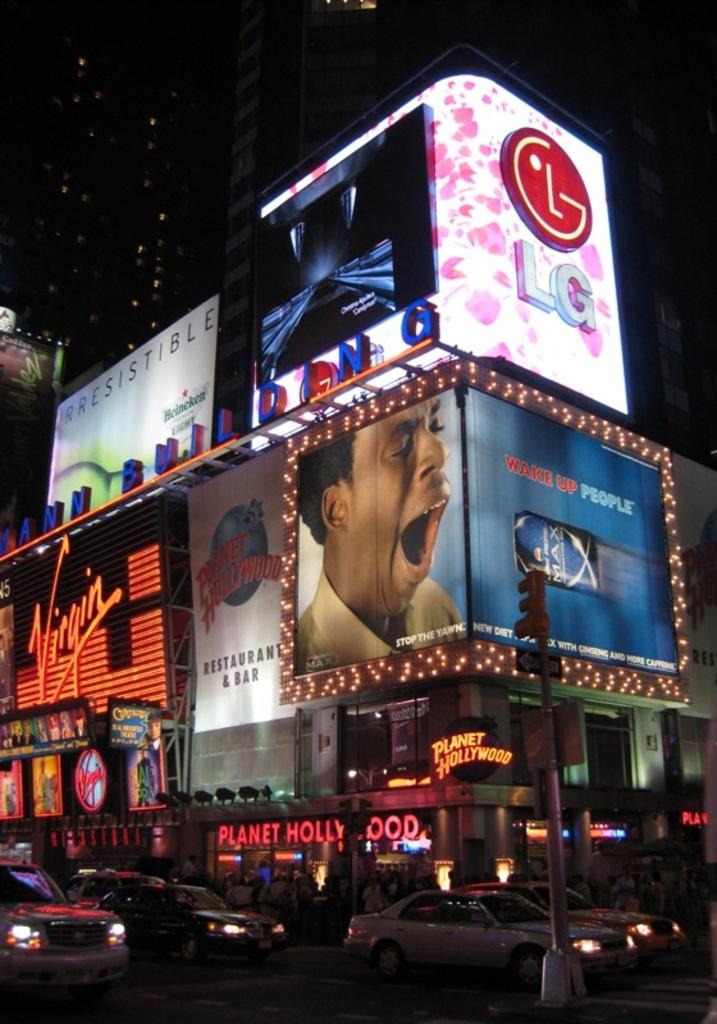What restaurant is that?
Provide a succinct answer. Planet hollywood. What cellphone company is advertised?
Keep it short and to the point. Lg. 